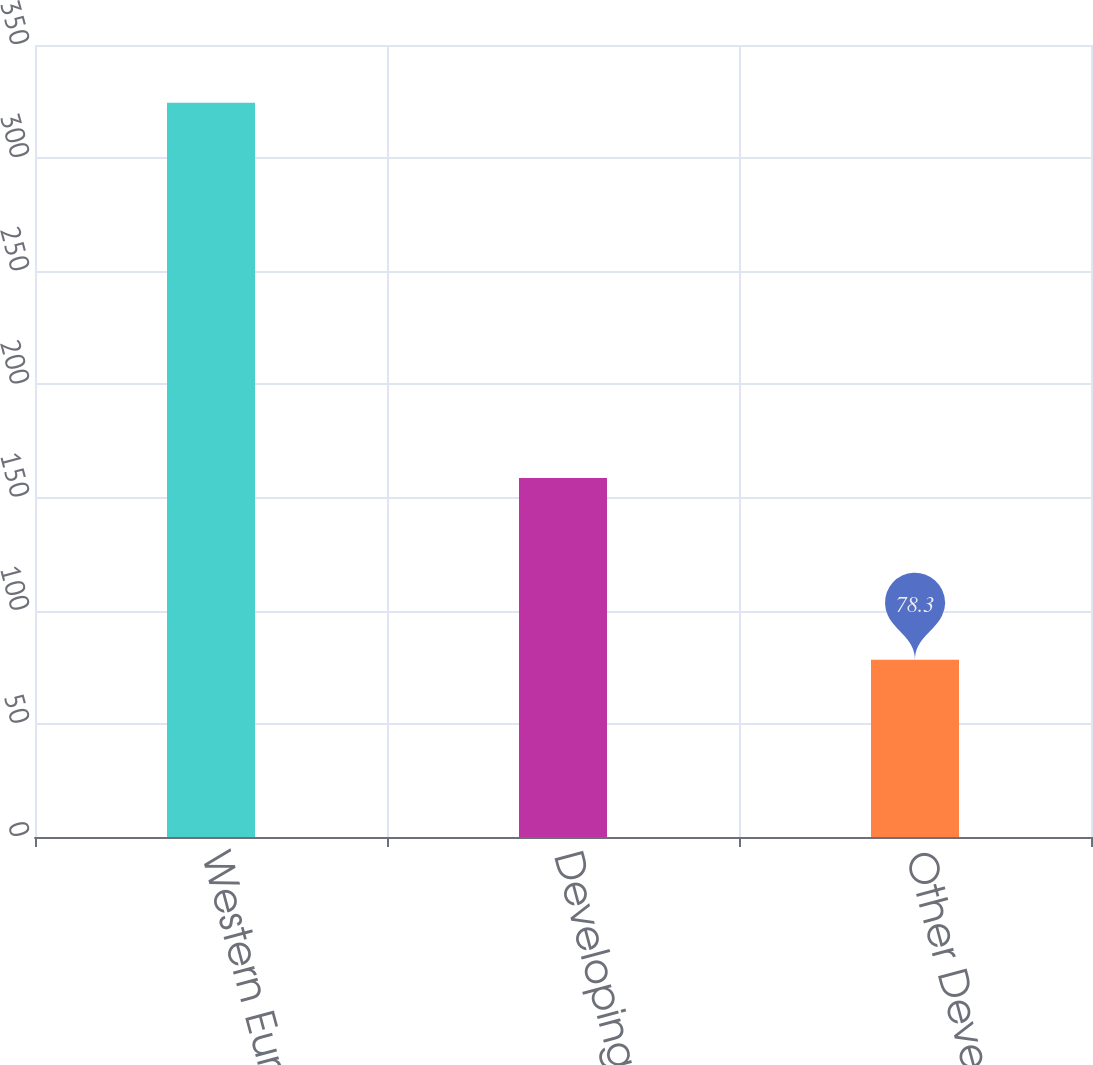<chart> <loc_0><loc_0><loc_500><loc_500><bar_chart><fcel>Western Europe<fcel>Developing (1)<fcel>Other Developed (2)<nl><fcel>324.5<fcel>158.6<fcel>78.3<nl></chart> 